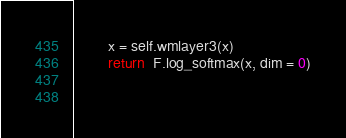<code> <loc_0><loc_0><loc_500><loc_500><_Python_>        x = self.wmlayer3(x)
        return  F.log_softmax(x, dim = 0)

        </code> 